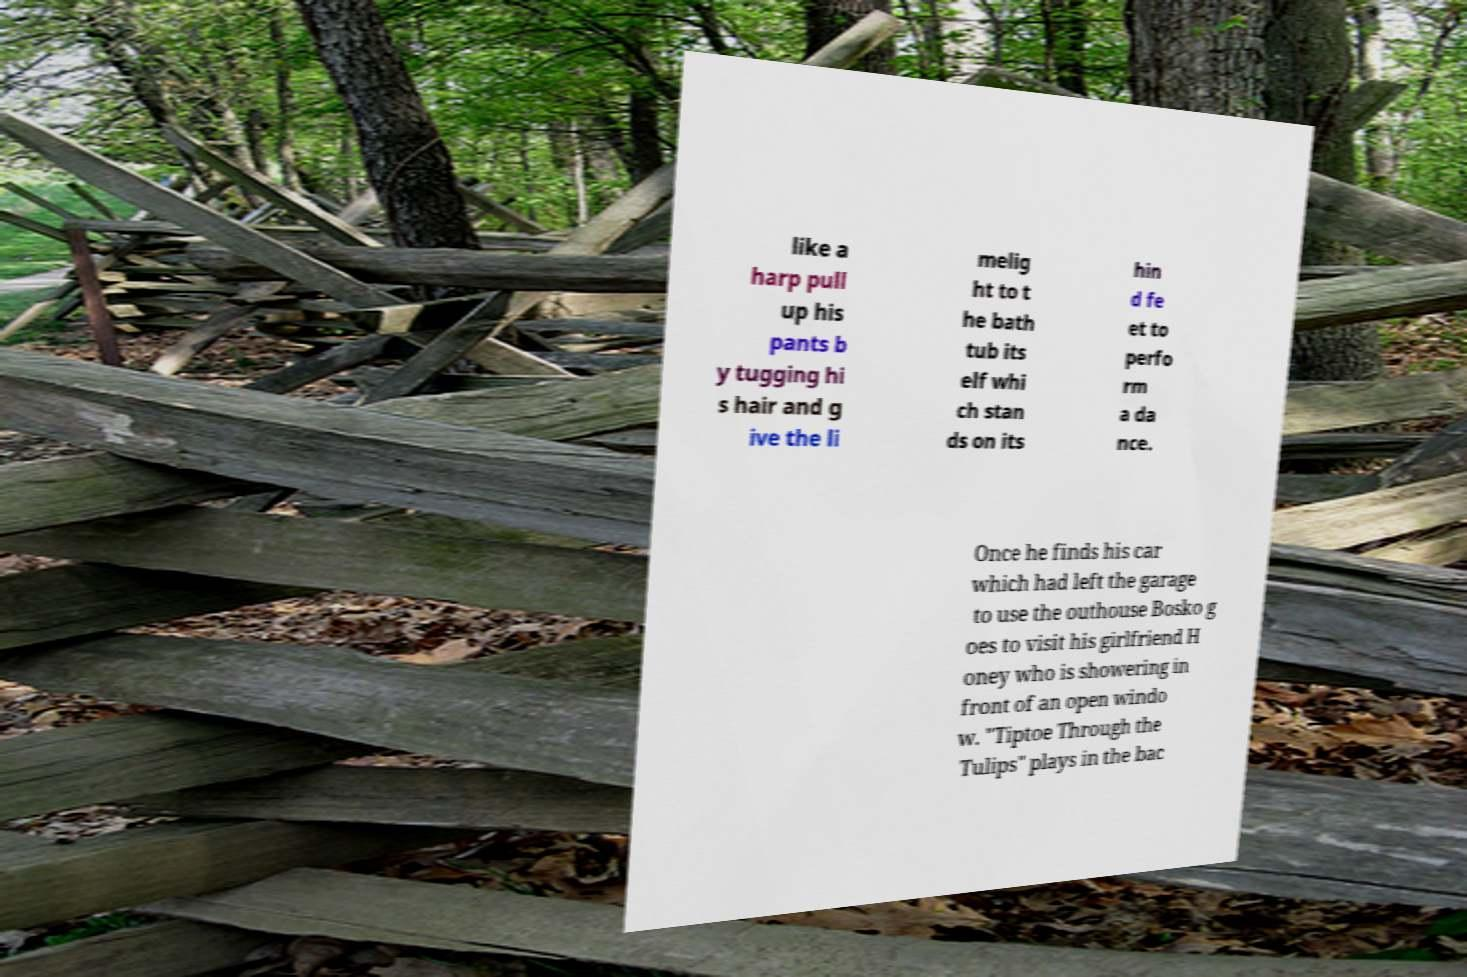Could you assist in decoding the text presented in this image and type it out clearly? like a harp pull up his pants b y tugging hi s hair and g ive the li melig ht to t he bath tub its elf whi ch stan ds on its hin d fe et to perfo rm a da nce. Once he finds his car which had left the garage to use the outhouse Bosko g oes to visit his girlfriend H oney who is showering in front of an open windo w. "Tiptoe Through the Tulips" plays in the bac 